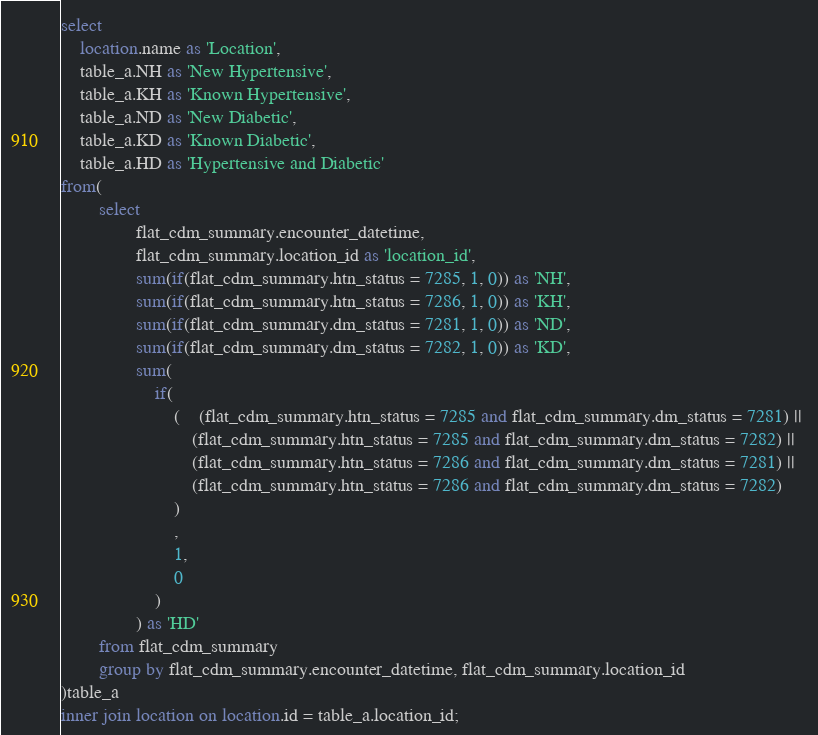Convert code to text. <code><loc_0><loc_0><loc_500><loc_500><_SQL_>select 
	location.name as 'Location',
	table_a.NH as 'New Hypertensive',
	table_a.KH as 'Known Hypertensive',
	table_a.ND as 'New Diabetic',
	table_a.KD as 'Known Diabetic',
	table_a.HD as 'Hypertensive and Diabetic'
from(
		select
				flat_cdm_summary.encounter_datetime,
				flat_cdm_summary.location_id as 'location_id',
				sum(if(flat_cdm_summary.htn_status = 7285, 1, 0)) as 'NH',
				sum(if(flat_cdm_summary.htn_status = 7286, 1, 0)) as 'KH',
				sum(if(flat_cdm_summary.dm_status = 7281, 1, 0)) as 'ND',
				sum(if(flat_cdm_summary.dm_status = 7282, 1, 0)) as 'KD',
				sum(
					if(
						(	(flat_cdm_summary.htn_status = 7285 and flat_cdm_summary.dm_status = 7281) || 
							(flat_cdm_summary.htn_status = 7285 and flat_cdm_summary.dm_status = 7282) ||
							(flat_cdm_summary.htn_status = 7286 and flat_cdm_summary.dm_status = 7281) ||
							(flat_cdm_summary.htn_status = 7286 and flat_cdm_summary.dm_status = 7282)
						)
						, 
						1, 
						0
					)
				) as 'HD'
		from flat_cdm_summary
		group by flat_cdm_summary.encounter_datetime, flat_cdm_summary.location_id
)table_a
inner join location on location.id = table_a.location_id;</code> 